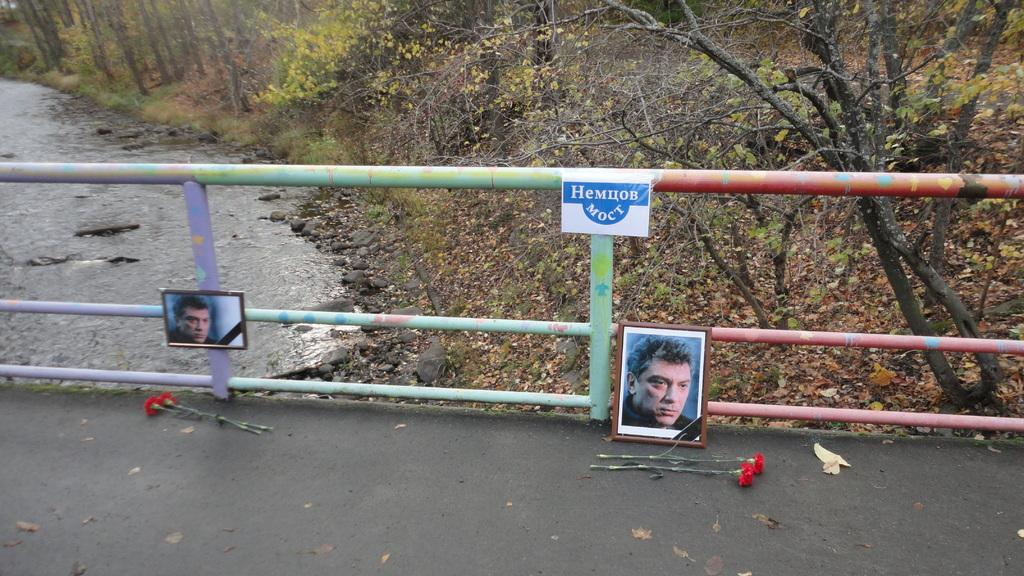What is present in the image that separates areas or provides a barrier? There is a fencing in the image. What can be seen on the fencing? There are two pictures of people on the fencing. What is placed in front of the pictures on the fencing? There are flowers in front of the pictures. What type of natural body of water is visible in the image? There is a lake visible in the image. What type of vegetation is present in the image? There are trees and plants in the image. What type of bone can be seen hanging from the fencing in the image? There is no bone present in the image; it only features a fencing with pictures of people and flowers in front of them. 